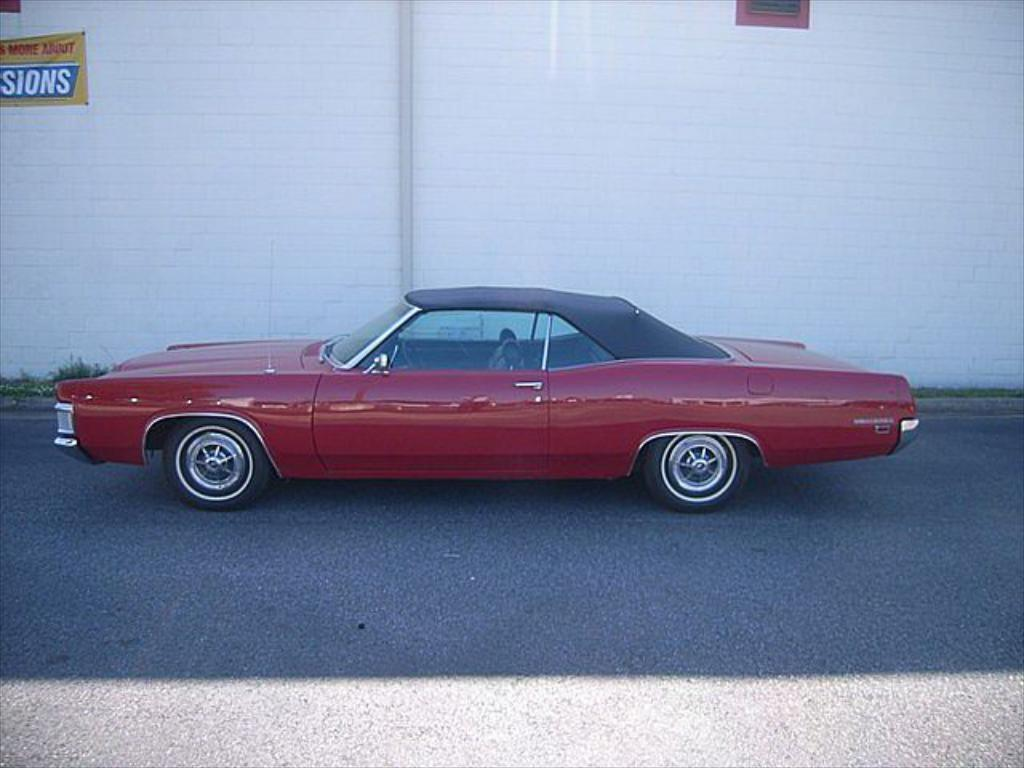What is the main subject of the image? There is a vehicle on the road in the image. What else can be seen in the image besides the vehicle? There is text written on a poster in the top left corner of the image, and a wall is visible in the background. What color is the patch on the balloon in the image? There is no patch or balloon present in the image. Is the rain visible in the image? The image does not show any rain; it only shows a vehicle on the road, text on a poster, and a wall in the background. 